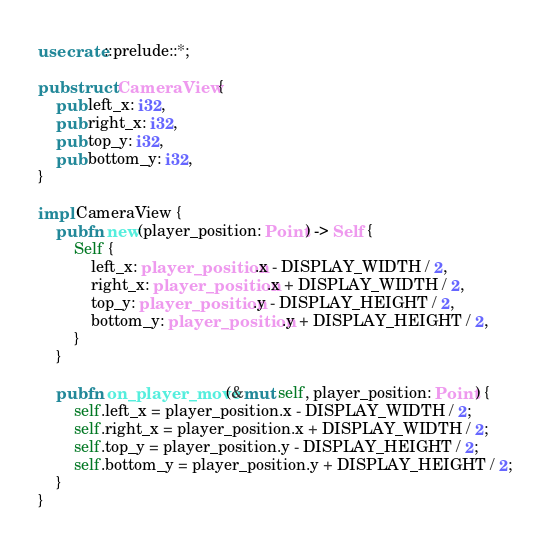Convert code to text. <code><loc_0><loc_0><loc_500><loc_500><_Rust_>use crate::prelude::*;

pub struct CameraView {
    pub left_x: i32,
    pub right_x: i32,
    pub top_y: i32,
    pub bottom_y: i32,
}

impl CameraView {
    pub fn new(player_position: Point) -> Self {
        Self {
            left_x: player_position.x - DISPLAY_WIDTH / 2,
            right_x: player_position.x + DISPLAY_WIDTH / 2,
            top_y: player_position.y - DISPLAY_HEIGHT / 2,
            bottom_y: player_position.y + DISPLAY_HEIGHT / 2,
        }
    }

    pub fn on_player_move(&mut self, player_position: Point) {
        self.left_x = player_position.x - DISPLAY_WIDTH / 2;
        self.right_x = player_position.x + DISPLAY_WIDTH / 2;
        self.top_y = player_position.y - DISPLAY_HEIGHT / 2;
        self.bottom_y = player_position.y + DISPLAY_HEIGHT / 2;
    }
}
</code> 